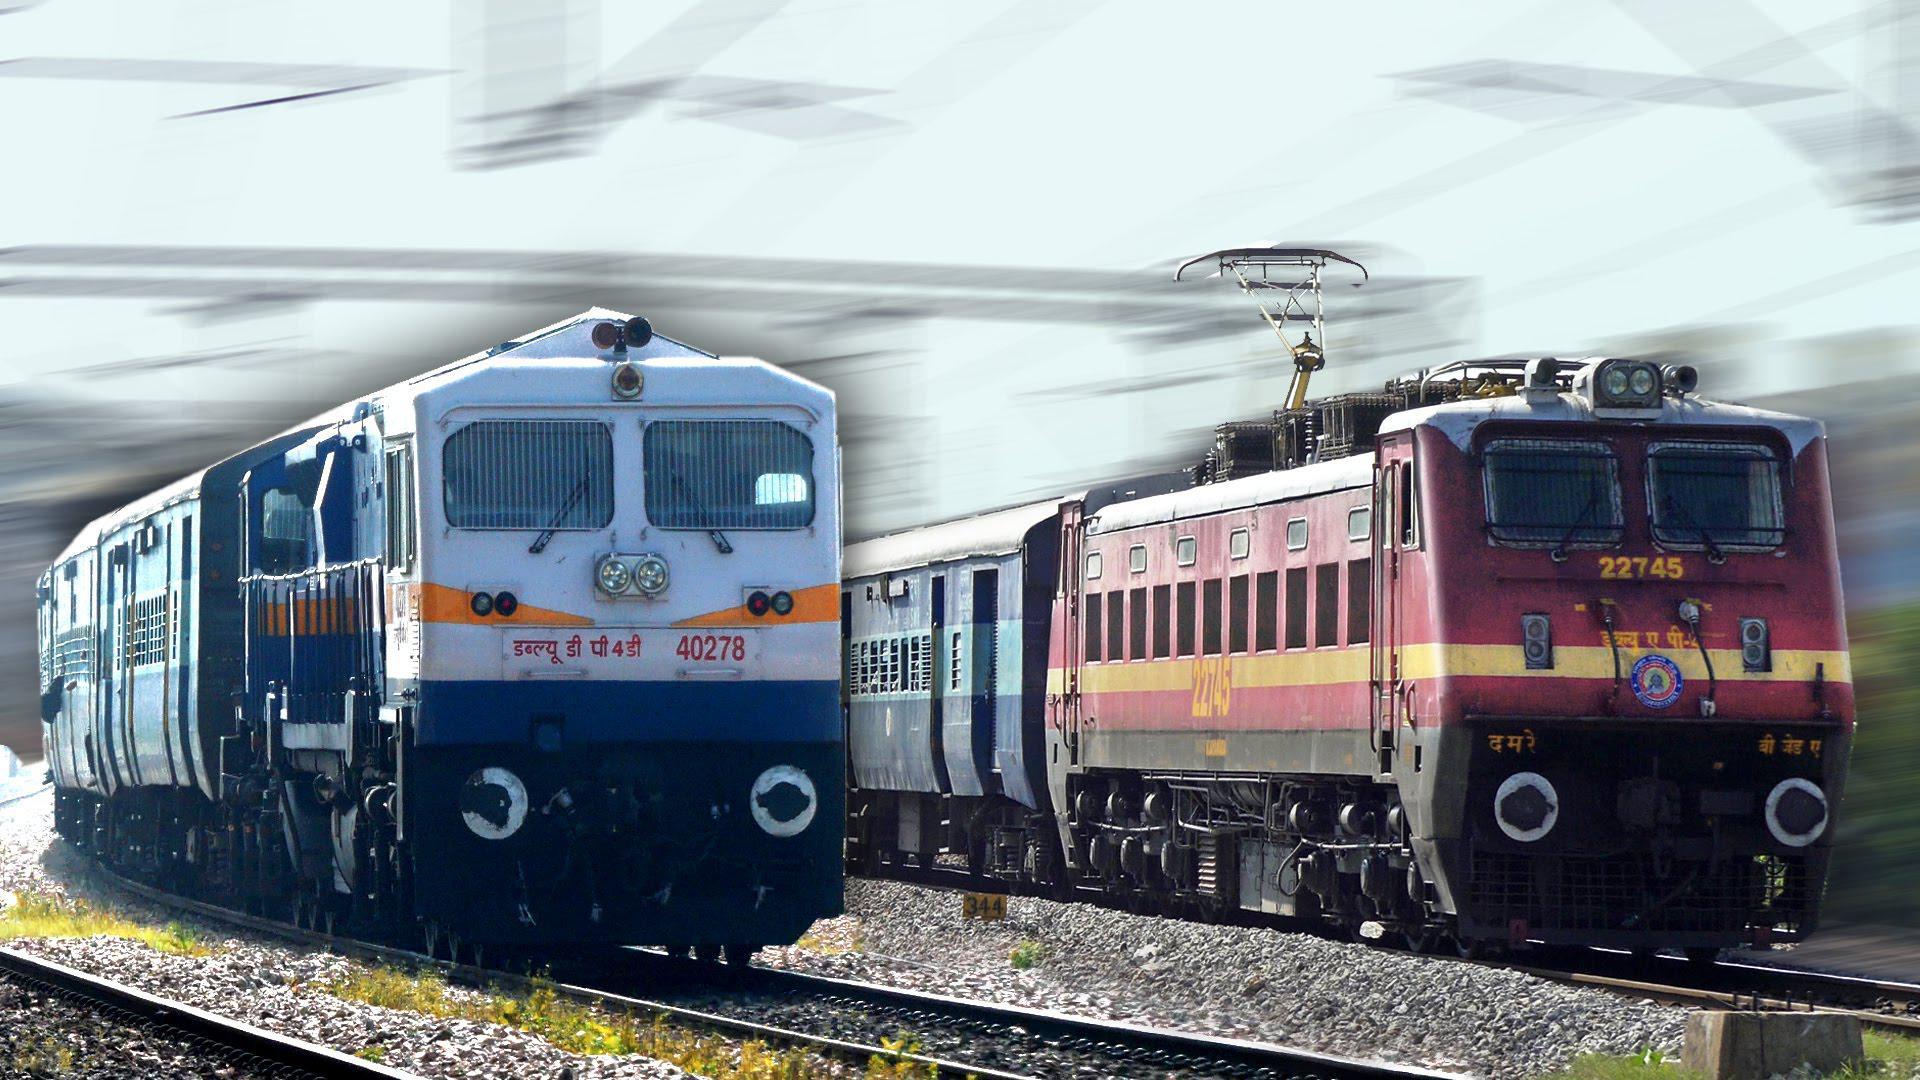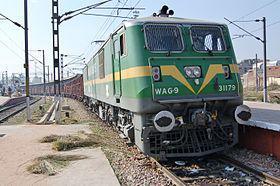The first image is the image on the left, the second image is the image on the right. Examine the images to the left and right. Is the description "A green train, with yellow trim and two square end windows, is sitting on the tracks on a sunny day." accurate? Answer yes or no. Yes. 